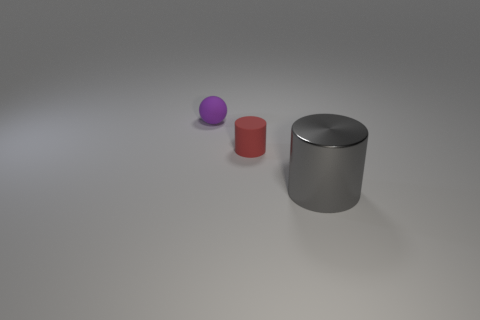Is the color of the small object to the right of the purple rubber object the same as the cylinder that is right of the small red rubber object?
Your response must be concise. No. Are there fewer large yellow rubber spheres than rubber spheres?
Provide a short and direct response. Yes. What shape is the small matte thing to the right of the tiny object that is on the left side of the tiny red matte object?
Offer a terse response. Cylinder. Is there anything else that has the same size as the shiny object?
Make the answer very short. No. The small matte thing that is in front of the tiny matte object behind the rubber thing in front of the tiny matte ball is what shape?
Your answer should be compact. Cylinder. What number of objects are tiny things that are to the right of the small sphere or small objects in front of the tiny purple thing?
Keep it short and to the point. 1. Do the metal cylinder and the cylinder that is on the left side of the gray object have the same size?
Offer a terse response. No. Is the cylinder behind the large gray shiny cylinder made of the same material as the cylinder on the right side of the red rubber cylinder?
Your response must be concise. No. Are there an equal number of purple matte objects right of the tiny purple thing and tiny objects that are in front of the metal thing?
Make the answer very short. Yes. How many other small matte cylinders are the same color as the tiny cylinder?
Offer a very short reply. 0. 